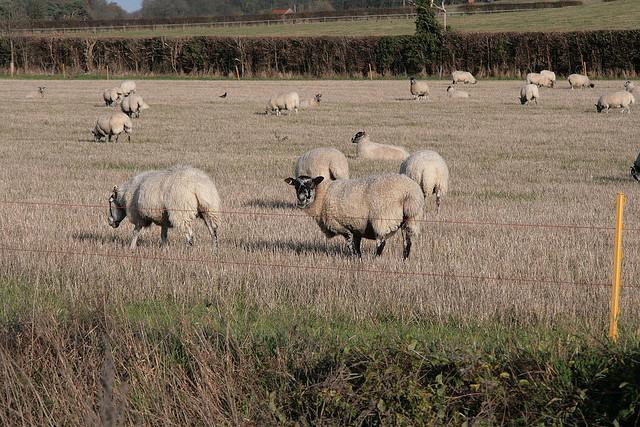How many sheep can be seen?
Give a very brief answer. 2. 